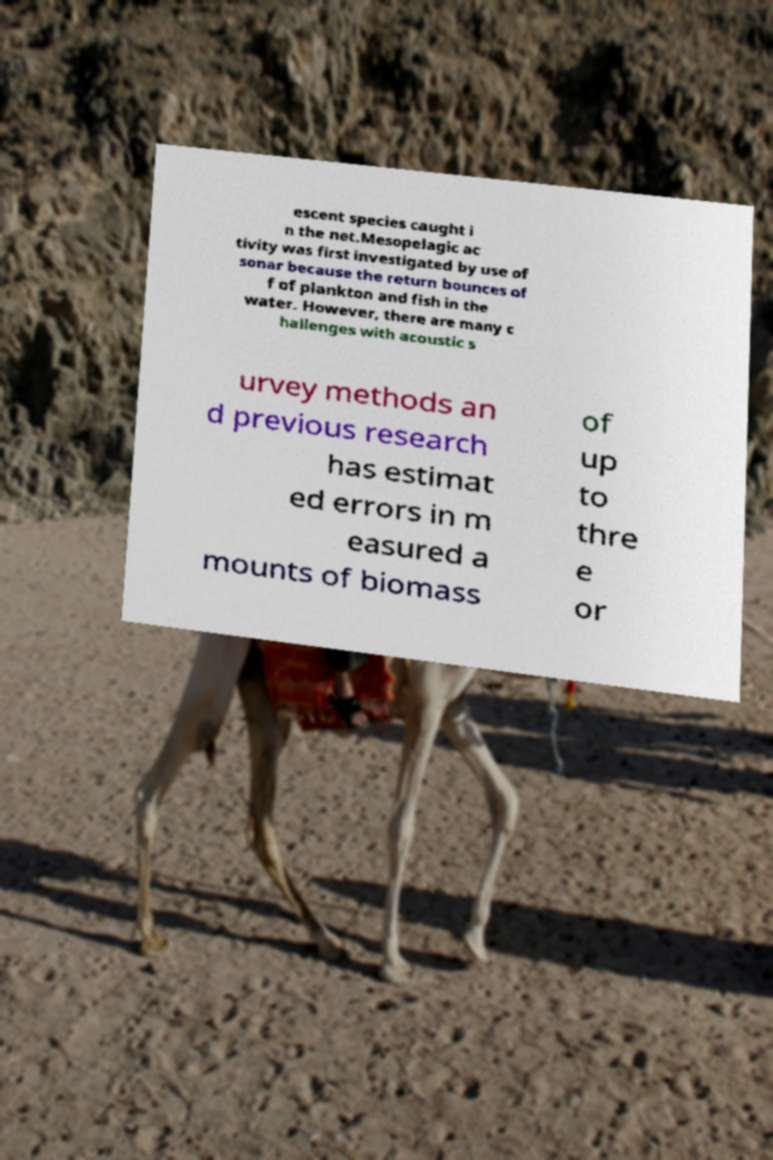I need the written content from this picture converted into text. Can you do that? escent species caught i n the net.Mesopelagic ac tivity was first investigated by use of sonar because the return bounces of f of plankton and fish in the water. However, there are many c hallenges with acoustic s urvey methods an d previous research has estimat ed errors in m easured a mounts of biomass of up to thre e or 